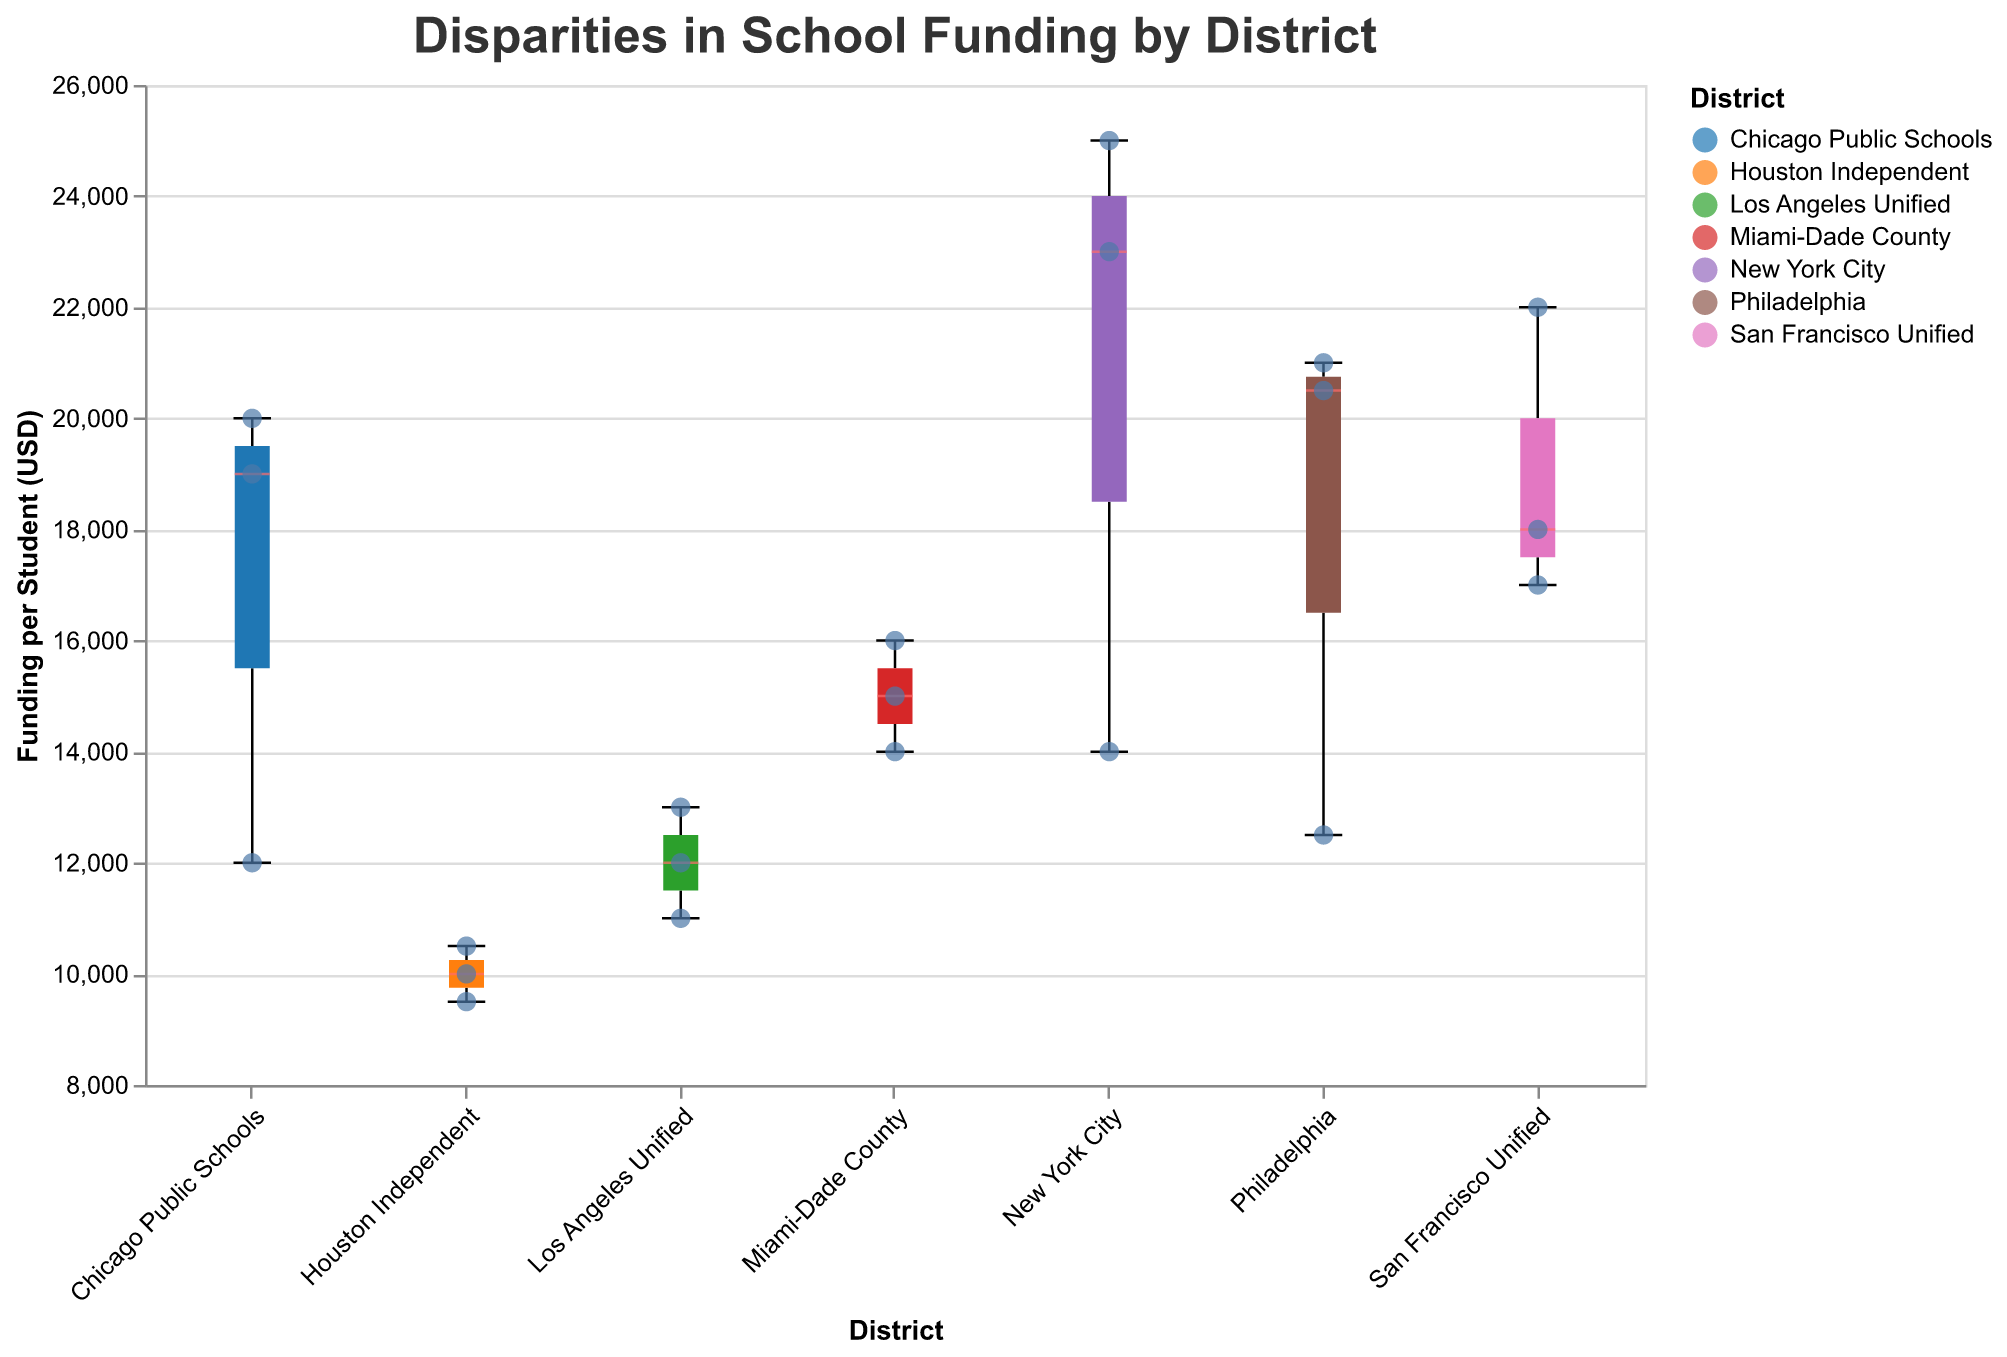What's the title of the figure? The title of the figure is given at the top and it reads "Disparities in School Funding by District."
Answer: Disparities in School Funding by District How many districts are represented in the figure? The X-axis contains labels for each district. Counting these labels, we find there are 6 districts represented.
Answer: 6 Which school has the highest funding per student in the Los Angeles Unified district? Looking at the scatter points for the Los Angeles Unified district, the highest point corresponds to Lincoln High School with $13,000 funding per student.
Answer: Lincoln High School What is the median funding per student for the San Francisco Unified district? The median value is shown inside the box plot as a line. For San Francisco Unified, the line is around $18,000.
Answer: $18,000 Compare the funding per student in New York City with Philadelphia. Which district has a higher median funding? The median funding is represented by the middle line in each box plot. New York City's median funding is higher, around $23,000, while Philadelphia's is around $20,000.
Answer: New York City What is the funding per student for the school with the highest test scores? The tooltip shows details for each scatter point. Stuyvesant High School in New York City has the highest test scores of 95 and a funding per student of $25,000.
Answer: $25,000 What is the range of funding per student in the Houston Independent district? The range is the difference between the maximum and minimum values represented by the ends of the whiskers. For Houston Independent, it ranges from about $9,500 to $10,500.
Answer: $9,500 to $10,500 In which district is the school with the lowest funding located, and what is this amount? By checking the bottom-most point among all districts, Bellaire High School in the Houston Independent district has the lowest funding per student at $9,500.
Answer: Houston Independent, $9,500 Which three districts show the most similar median funding per student? Comparing the median lines across the box plots, Miami-Dade County, Los Angeles Unified, and Houston Independent have median funding amounts close to each other, around $14,000 to $15,000.
Answer: Miami-Dade County, Los Angeles Unified, Houston Independent What pattern can you observe about the relationship between funding per student and the graduation rate from the points shown? Many high-scoring points also represent high funding and high graduation rates schools, indicating that higher funding often correlates with higher graduation rates.
Answer: Higher funding often correlates with higher graduation rates 